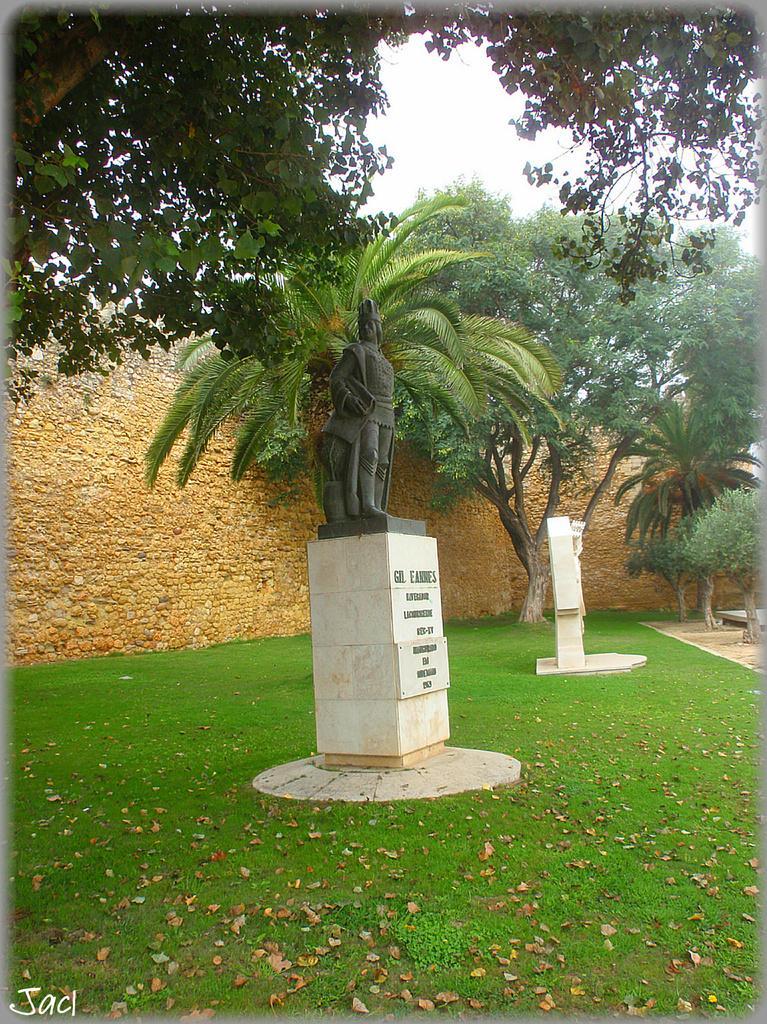How would you summarize this image in a sentence or two? In this image I can see the statue. In the background I see the wall in brown color, few trees in green color and the sky is in white color. 